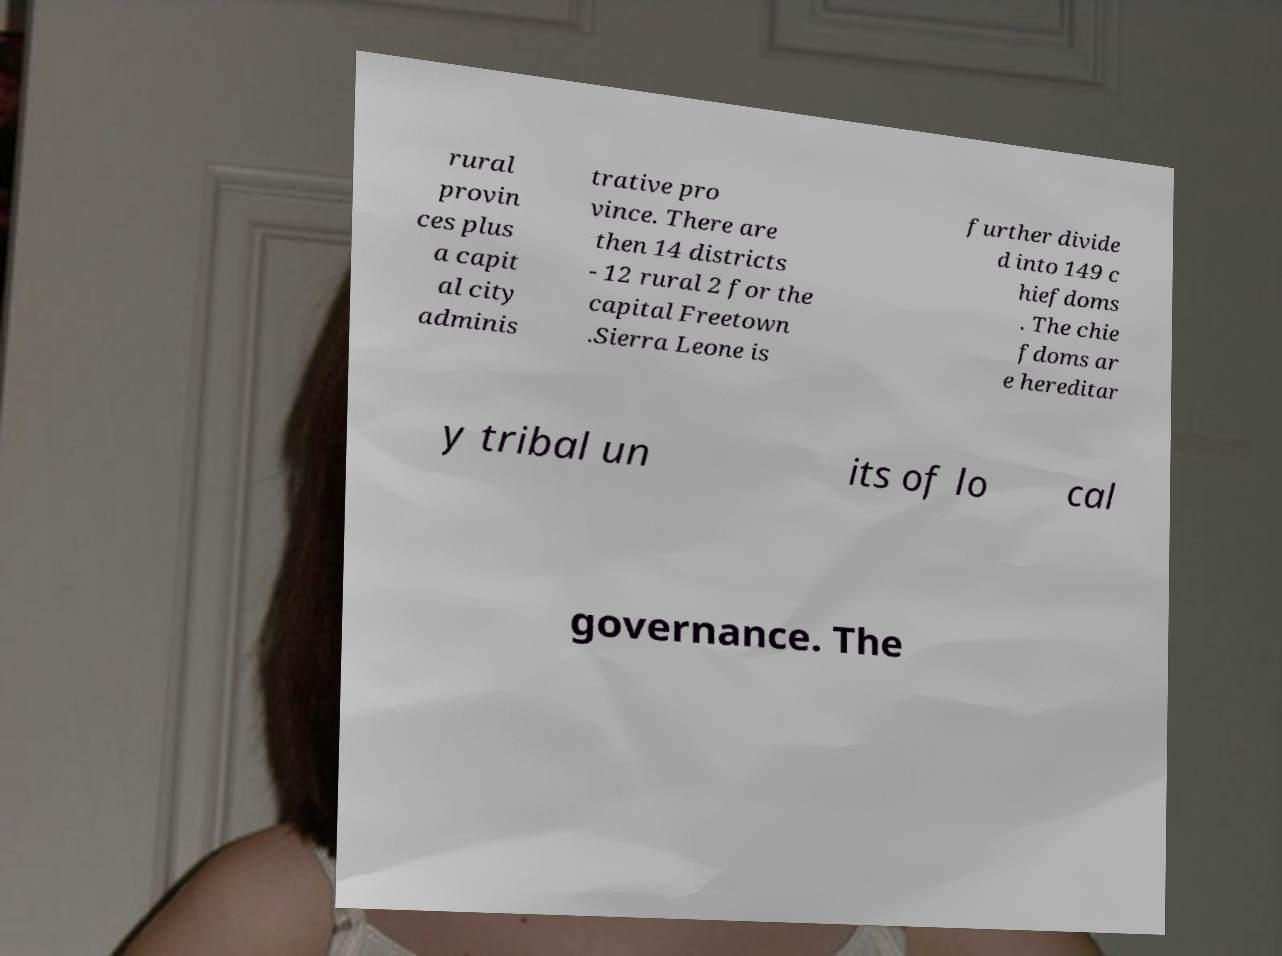Please identify and transcribe the text found in this image. rural provin ces plus a capit al city adminis trative pro vince. There are then 14 districts - 12 rural 2 for the capital Freetown .Sierra Leone is further divide d into 149 c hiefdoms . The chie fdoms ar e hereditar y tribal un its of lo cal governance. The 